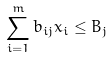<formula> <loc_0><loc_0><loc_500><loc_500>\sum _ { i = 1 } ^ { m } b _ { i j } x _ { i } \leq B _ { j }</formula> 